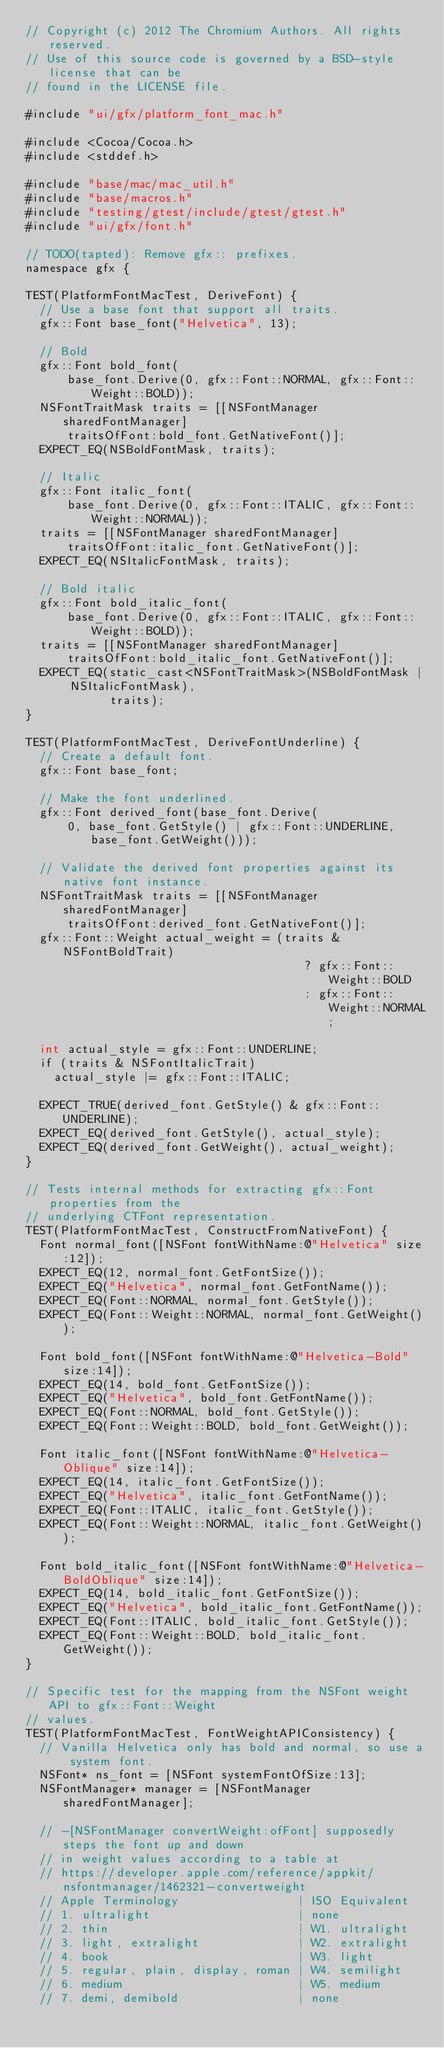Convert code to text. <code><loc_0><loc_0><loc_500><loc_500><_ObjectiveC_>// Copyright (c) 2012 The Chromium Authors. All rights reserved.
// Use of this source code is governed by a BSD-style license that can be
// found in the LICENSE file.

#include "ui/gfx/platform_font_mac.h"

#include <Cocoa/Cocoa.h>
#include <stddef.h>

#include "base/mac/mac_util.h"
#include "base/macros.h"
#include "testing/gtest/include/gtest/gtest.h"
#include "ui/gfx/font.h"

// TODO(tapted): Remove gfx:: prefixes.
namespace gfx {

TEST(PlatformFontMacTest, DeriveFont) {
  // Use a base font that support all traits.
  gfx::Font base_font("Helvetica", 13);

  // Bold
  gfx::Font bold_font(
      base_font.Derive(0, gfx::Font::NORMAL, gfx::Font::Weight::BOLD));
  NSFontTraitMask traits = [[NSFontManager sharedFontManager]
      traitsOfFont:bold_font.GetNativeFont()];
  EXPECT_EQ(NSBoldFontMask, traits);

  // Italic
  gfx::Font italic_font(
      base_font.Derive(0, gfx::Font::ITALIC, gfx::Font::Weight::NORMAL));
  traits = [[NSFontManager sharedFontManager]
      traitsOfFont:italic_font.GetNativeFont()];
  EXPECT_EQ(NSItalicFontMask, traits);

  // Bold italic
  gfx::Font bold_italic_font(
      base_font.Derive(0, gfx::Font::ITALIC, gfx::Font::Weight::BOLD));
  traits = [[NSFontManager sharedFontManager]
      traitsOfFont:bold_italic_font.GetNativeFont()];
  EXPECT_EQ(static_cast<NSFontTraitMask>(NSBoldFontMask | NSItalicFontMask),
            traits);
}

TEST(PlatformFontMacTest, DeriveFontUnderline) {
  // Create a default font.
  gfx::Font base_font;

  // Make the font underlined.
  gfx::Font derived_font(base_font.Derive(
      0, base_font.GetStyle() | gfx::Font::UNDERLINE, base_font.GetWeight()));

  // Validate the derived font properties against its native font instance.
  NSFontTraitMask traits = [[NSFontManager sharedFontManager]
      traitsOfFont:derived_font.GetNativeFont()];
  gfx::Font::Weight actual_weight = (traits & NSFontBoldTrait)
                                        ? gfx::Font::Weight::BOLD
                                        : gfx::Font::Weight::NORMAL;

  int actual_style = gfx::Font::UNDERLINE;
  if (traits & NSFontItalicTrait)
    actual_style |= gfx::Font::ITALIC;

  EXPECT_TRUE(derived_font.GetStyle() & gfx::Font::UNDERLINE);
  EXPECT_EQ(derived_font.GetStyle(), actual_style);
  EXPECT_EQ(derived_font.GetWeight(), actual_weight);
}

// Tests internal methods for extracting gfx::Font properties from the
// underlying CTFont representation.
TEST(PlatformFontMacTest, ConstructFromNativeFont) {
  Font normal_font([NSFont fontWithName:@"Helvetica" size:12]);
  EXPECT_EQ(12, normal_font.GetFontSize());
  EXPECT_EQ("Helvetica", normal_font.GetFontName());
  EXPECT_EQ(Font::NORMAL, normal_font.GetStyle());
  EXPECT_EQ(Font::Weight::NORMAL, normal_font.GetWeight());

  Font bold_font([NSFont fontWithName:@"Helvetica-Bold" size:14]);
  EXPECT_EQ(14, bold_font.GetFontSize());
  EXPECT_EQ("Helvetica", bold_font.GetFontName());
  EXPECT_EQ(Font::NORMAL, bold_font.GetStyle());
  EXPECT_EQ(Font::Weight::BOLD, bold_font.GetWeight());

  Font italic_font([NSFont fontWithName:@"Helvetica-Oblique" size:14]);
  EXPECT_EQ(14, italic_font.GetFontSize());
  EXPECT_EQ("Helvetica", italic_font.GetFontName());
  EXPECT_EQ(Font::ITALIC, italic_font.GetStyle());
  EXPECT_EQ(Font::Weight::NORMAL, italic_font.GetWeight());

  Font bold_italic_font([NSFont fontWithName:@"Helvetica-BoldOblique" size:14]);
  EXPECT_EQ(14, bold_italic_font.GetFontSize());
  EXPECT_EQ("Helvetica", bold_italic_font.GetFontName());
  EXPECT_EQ(Font::ITALIC, bold_italic_font.GetStyle());
  EXPECT_EQ(Font::Weight::BOLD, bold_italic_font.GetWeight());
}

// Specific test for the mapping from the NSFont weight API to gfx::Font::Weight
// values.
TEST(PlatformFontMacTest, FontWeightAPIConsistency) {
  // Vanilla Helvetica only has bold and normal, so use a system font.
  NSFont* ns_font = [NSFont systemFontOfSize:13];
  NSFontManager* manager = [NSFontManager sharedFontManager];

  // -[NSFontManager convertWeight:ofFont] supposedly steps the font up and down
  // in weight values according to a table at
  // https://developer.apple.com/reference/appkit/nsfontmanager/1462321-convertweight
  // Apple Terminology                 | ISO Equivalent
  // 1. ultralight                     | none
  // 2. thin                           | W1. ultralight
  // 3. light, extralight              | W2. extralight
  // 4. book                           | W3. light
  // 5. regular, plain, display, roman | W4. semilight
  // 6. medium                         | W5. medium
  // 7. demi, demibold                 | none</code> 